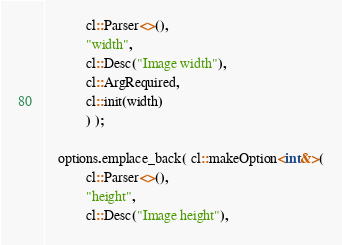Convert code to text. <code><loc_0><loc_0><loc_500><loc_500><_Cuda_>            cl::Parser<>(),
            "width",
            cl::Desc("Image width"),
            cl::ArgRequired,
            cl::init(width)
            ) );

    options.emplace_back( cl::makeOption<int&>(
            cl::Parser<>(),
            "height",
            cl::Desc("Image height"),</code> 